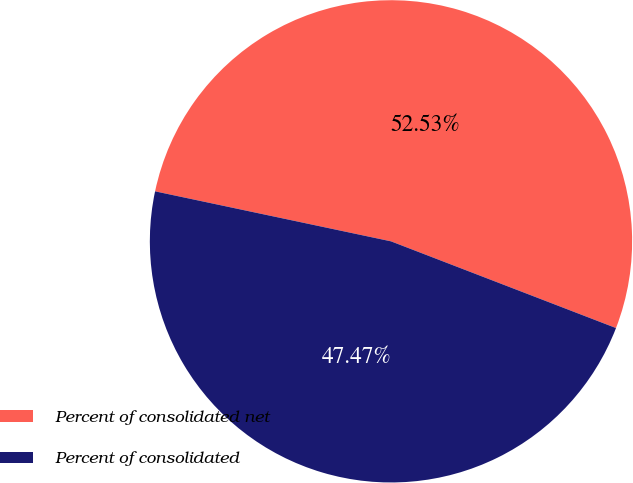<chart> <loc_0><loc_0><loc_500><loc_500><pie_chart><fcel>Percent of consolidated net<fcel>Percent of consolidated<nl><fcel>52.53%<fcel>47.47%<nl></chart> 